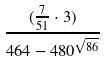<formula> <loc_0><loc_0><loc_500><loc_500>\frac { ( \frac { 7 } { 5 1 } \cdot 3 ) } { 4 6 4 - 4 8 0 ^ { \sqrt { 8 6 } } }</formula> 